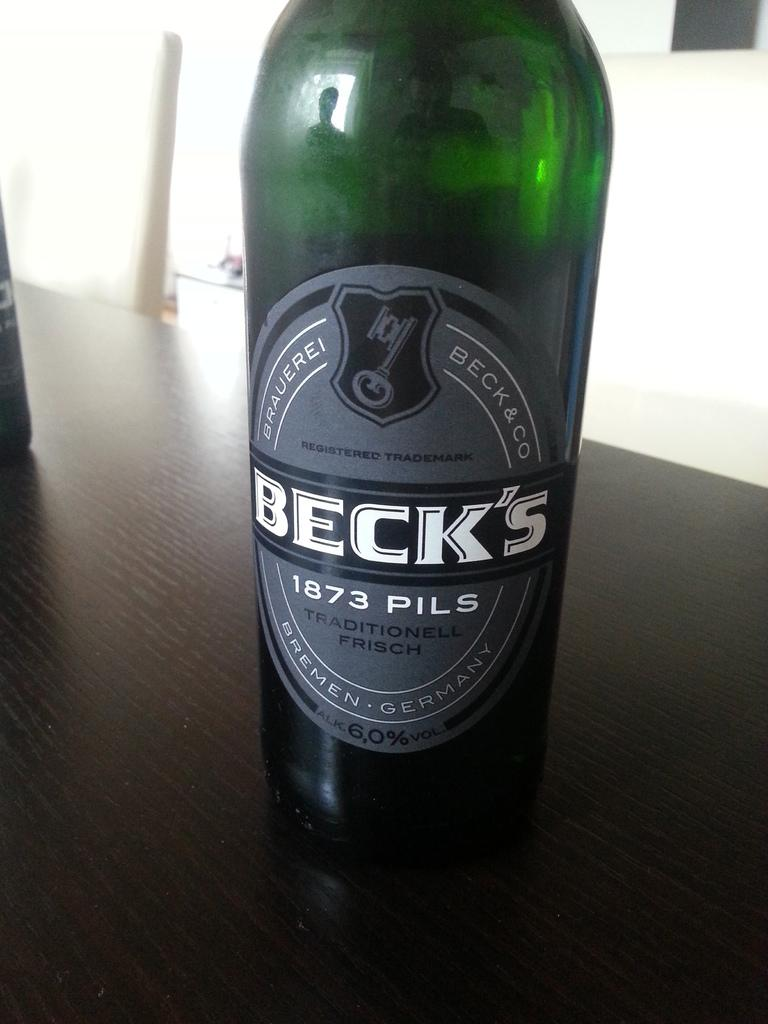Provide a one-sentence caption for the provided image. A green bottle of German beer called Beck's that is sitting on a brown table. 